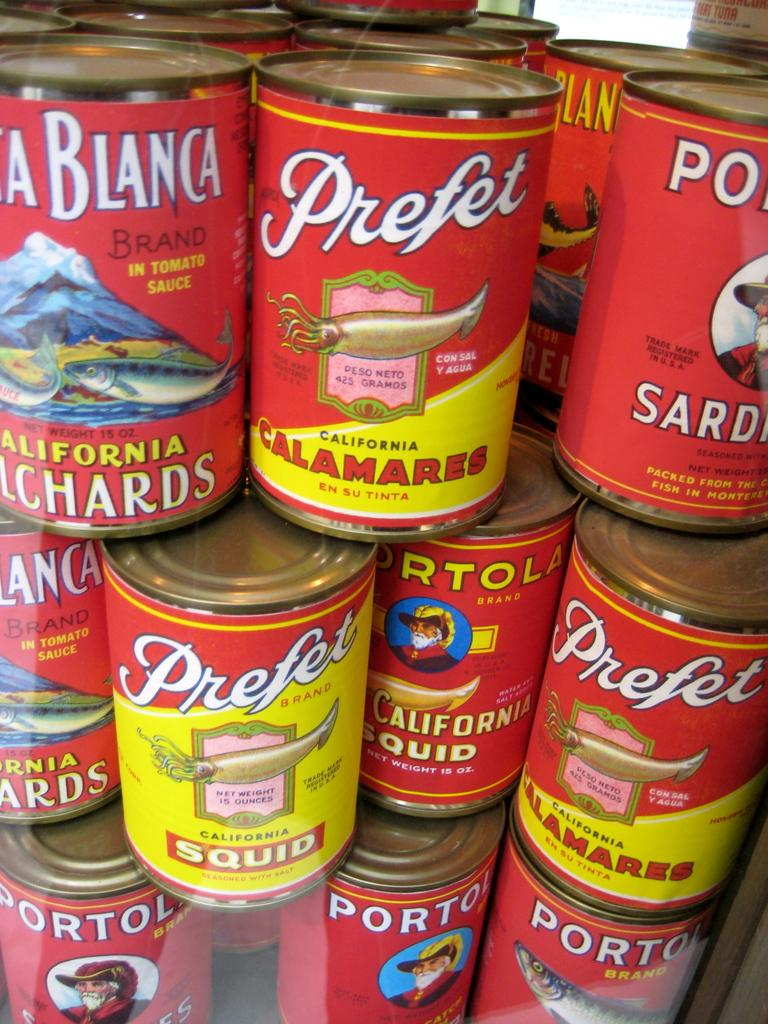<image>
Provide a brief description of the given image. a few cans with the name Prefet on some of them 